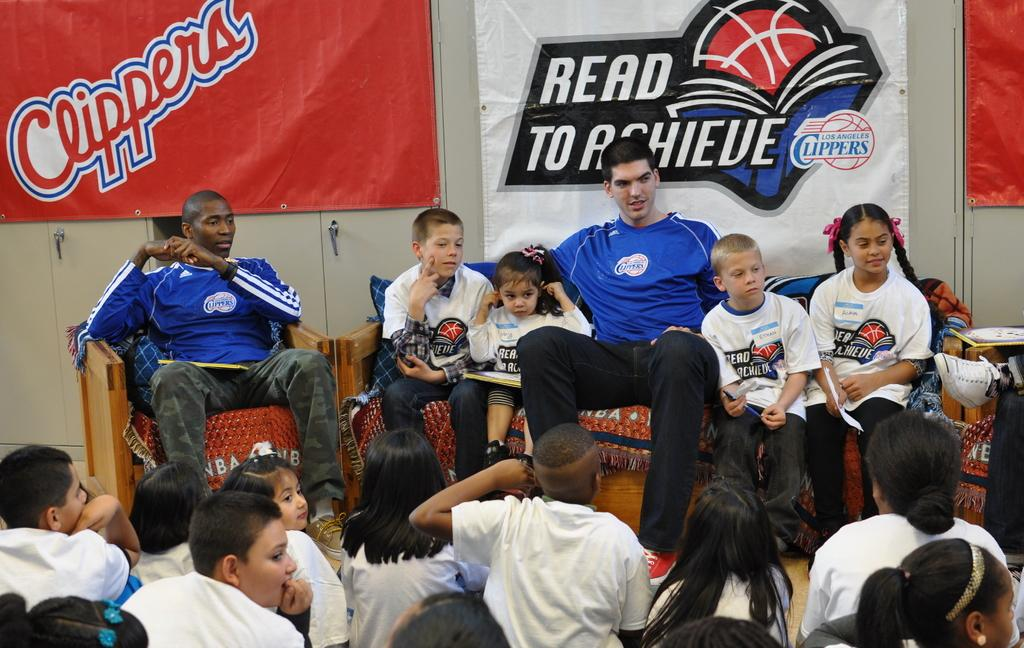Provide a one-sentence caption for the provided image. A group of clipper fans gathered together for a read to achieve group. 